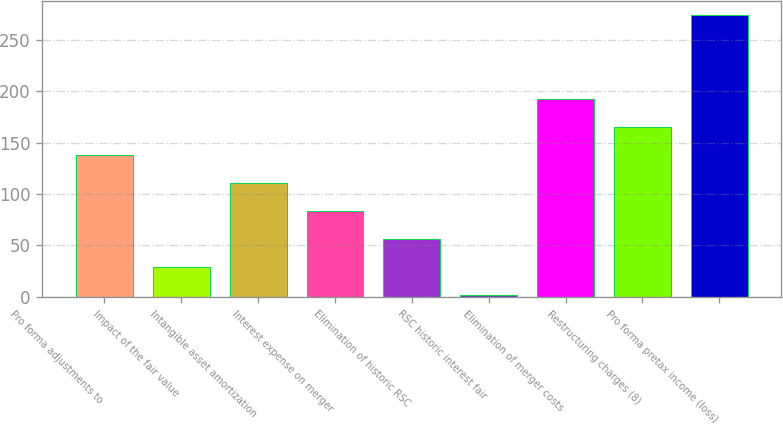Convert chart. <chart><loc_0><loc_0><loc_500><loc_500><bar_chart><fcel>Pro forma adjustments to<fcel>Impact of the fair value<fcel>Intangible asset amortization<fcel>Interest expense on merger<fcel>Elimination of historic RSC<fcel>RSC historic interest fair<fcel>Elimination of merger costs<fcel>Restructuring charges (8)<fcel>Pro forma pretax income (loss)<nl><fcel>138<fcel>29.2<fcel>110.8<fcel>83.6<fcel>56.4<fcel>2<fcel>192.4<fcel>165.2<fcel>274<nl></chart> 